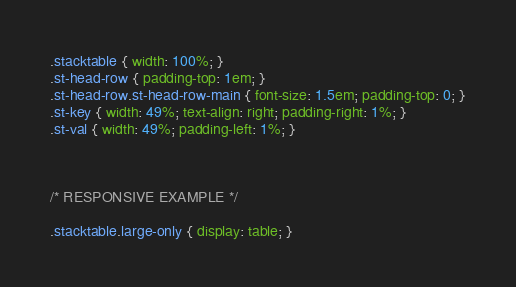<code> <loc_0><loc_0><loc_500><loc_500><_CSS_>.stacktable { width: 100%; }
.st-head-row { padding-top: 1em; }
.st-head-row.st-head-row-main { font-size: 1.5em; padding-top: 0; }
.st-key { width: 49%; text-align: right; padding-right: 1%; }
.st-val { width: 49%; padding-left: 1%; }



/* RESPONSIVE EXAMPLE */

.stacktable.large-only { display: table; }</code> 